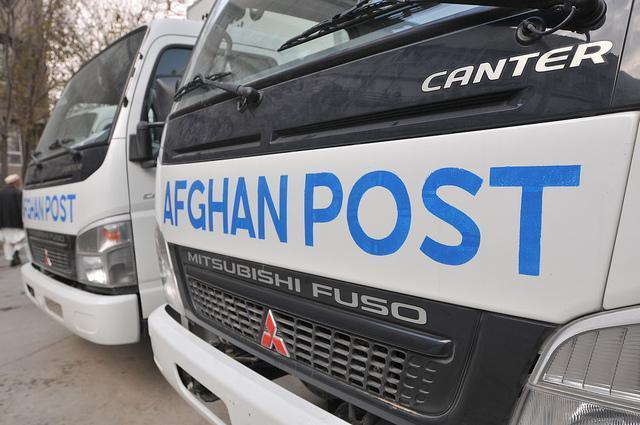How many trucks are in the photo?
Give a very brief answer. 2. 